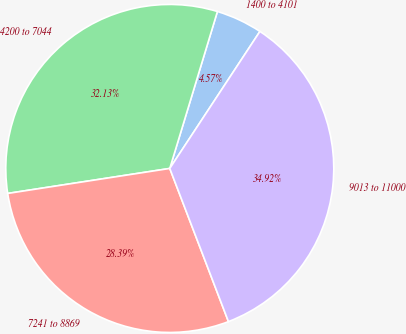<chart> <loc_0><loc_0><loc_500><loc_500><pie_chart><fcel>1400 to 4101<fcel>4200 to 7044<fcel>7241 to 8869<fcel>9013 to 11000<nl><fcel>4.57%<fcel>32.13%<fcel>28.39%<fcel>34.92%<nl></chart> 